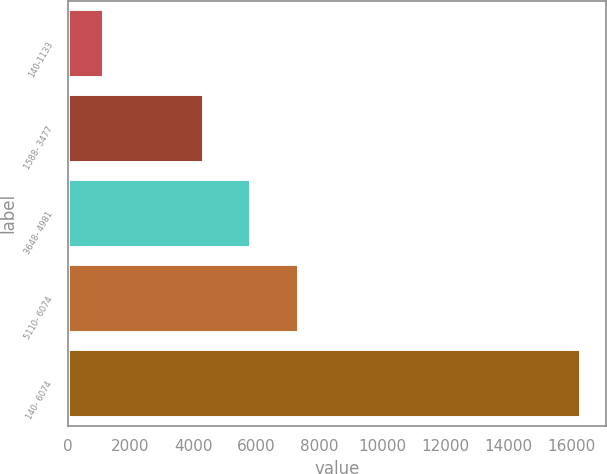<chart> <loc_0><loc_0><loc_500><loc_500><bar_chart><fcel>140-1133<fcel>1588- 3477<fcel>3648- 4981<fcel>5110- 6074<fcel>140- 6074<nl><fcel>1129<fcel>4293<fcel>5808.2<fcel>7323.4<fcel>16281<nl></chart> 